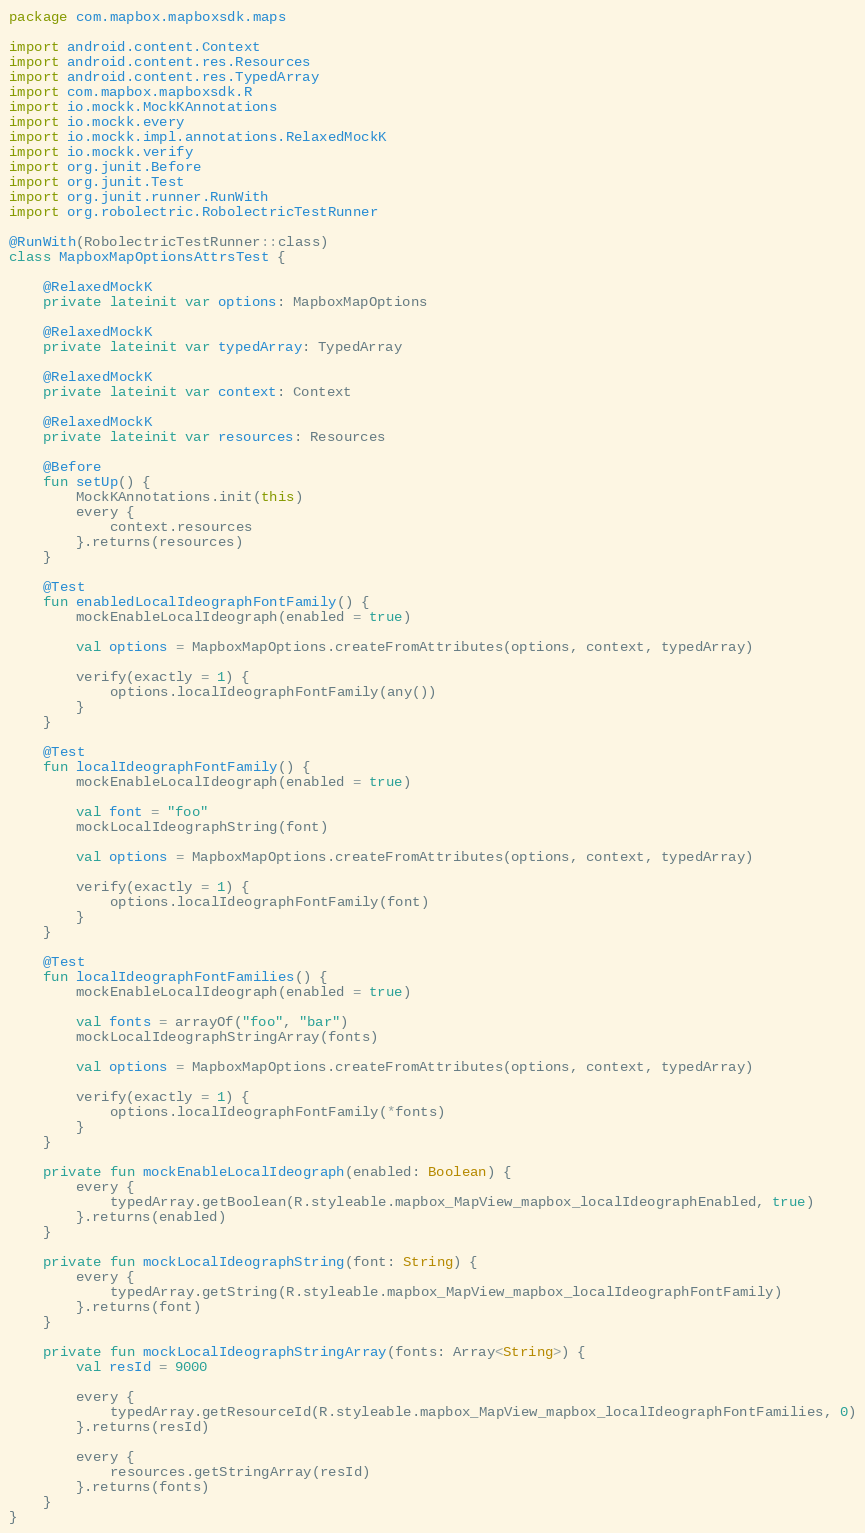Convert code to text. <code><loc_0><loc_0><loc_500><loc_500><_Kotlin_>package com.mapbox.mapboxsdk.maps

import android.content.Context
import android.content.res.Resources
import android.content.res.TypedArray
import com.mapbox.mapboxsdk.R
import io.mockk.MockKAnnotations
import io.mockk.every
import io.mockk.impl.annotations.RelaxedMockK
import io.mockk.verify
import org.junit.Before
import org.junit.Test
import org.junit.runner.RunWith
import org.robolectric.RobolectricTestRunner

@RunWith(RobolectricTestRunner::class)
class MapboxMapOptionsAttrsTest {

    @RelaxedMockK
    private lateinit var options: MapboxMapOptions

    @RelaxedMockK
    private lateinit var typedArray: TypedArray

    @RelaxedMockK
    private lateinit var context: Context

    @RelaxedMockK
    private lateinit var resources: Resources

    @Before
    fun setUp() {
        MockKAnnotations.init(this)
        every {
            context.resources
        }.returns(resources)
    }

    @Test
    fun enabledLocalIdeographFontFamily() {
        mockEnableLocalIdeograph(enabled = true)

        val options = MapboxMapOptions.createFromAttributes(options, context, typedArray)

        verify(exactly = 1) {
            options.localIdeographFontFamily(any())
        }
    }

    @Test
    fun localIdeographFontFamily() {
        mockEnableLocalIdeograph(enabled = true)

        val font = "foo"
        mockLocalIdeographString(font)

        val options = MapboxMapOptions.createFromAttributes(options, context, typedArray)

        verify(exactly = 1) {
            options.localIdeographFontFamily(font)
        }
    }

    @Test
    fun localIdeographFontFamilies() {
        mockEnableLocalIdeograph(enabled = true)

        val fonts = arrayOf("foo", "bar")
        mockLocalIdeographStringArray(fonts)

        val options = MapboxMapOptions.createFromAttributes(options, context, typedArray)

        verify(exactly = 1) {
            options.localIdeographFontFamily(*fonts)
        }
    }

    private fun mockEnableLocalIdeograph(enabled: Boolean) {
        every {
            typedArray.getBoolean(R.styleable.mapbox_MapView_mapbox_localIdeographEnabled, true)
        }.returns(enabled)
    }

    private fun mockLocalIdeographString(font: String) {
        every {
            typedArray.getString(R.styleable.mapbox_MapView_mapbox_localIdeographFontFamily)
        }.returns(font)
    }

    private fun mockLocalIdeographStringArray(fonts: Array<String>) {
        val resId = 9000

        every {
            typedArray.getResourceId(R.styleable.mapbox_MapView_mapbox_localIdeographFontFamilies, 0)
        }.returns(resId)

        every {
            resources.getStringArray(resId)
        }.returns(fonts)
    }
}
</code> 